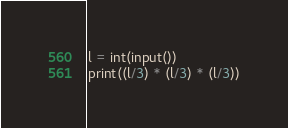Convert code to text. <code><loc_0><loc_0><loc_500><loc_500><_Python_>l = int(input())
print((l/3) * (l/3) * (l/3))</code> 